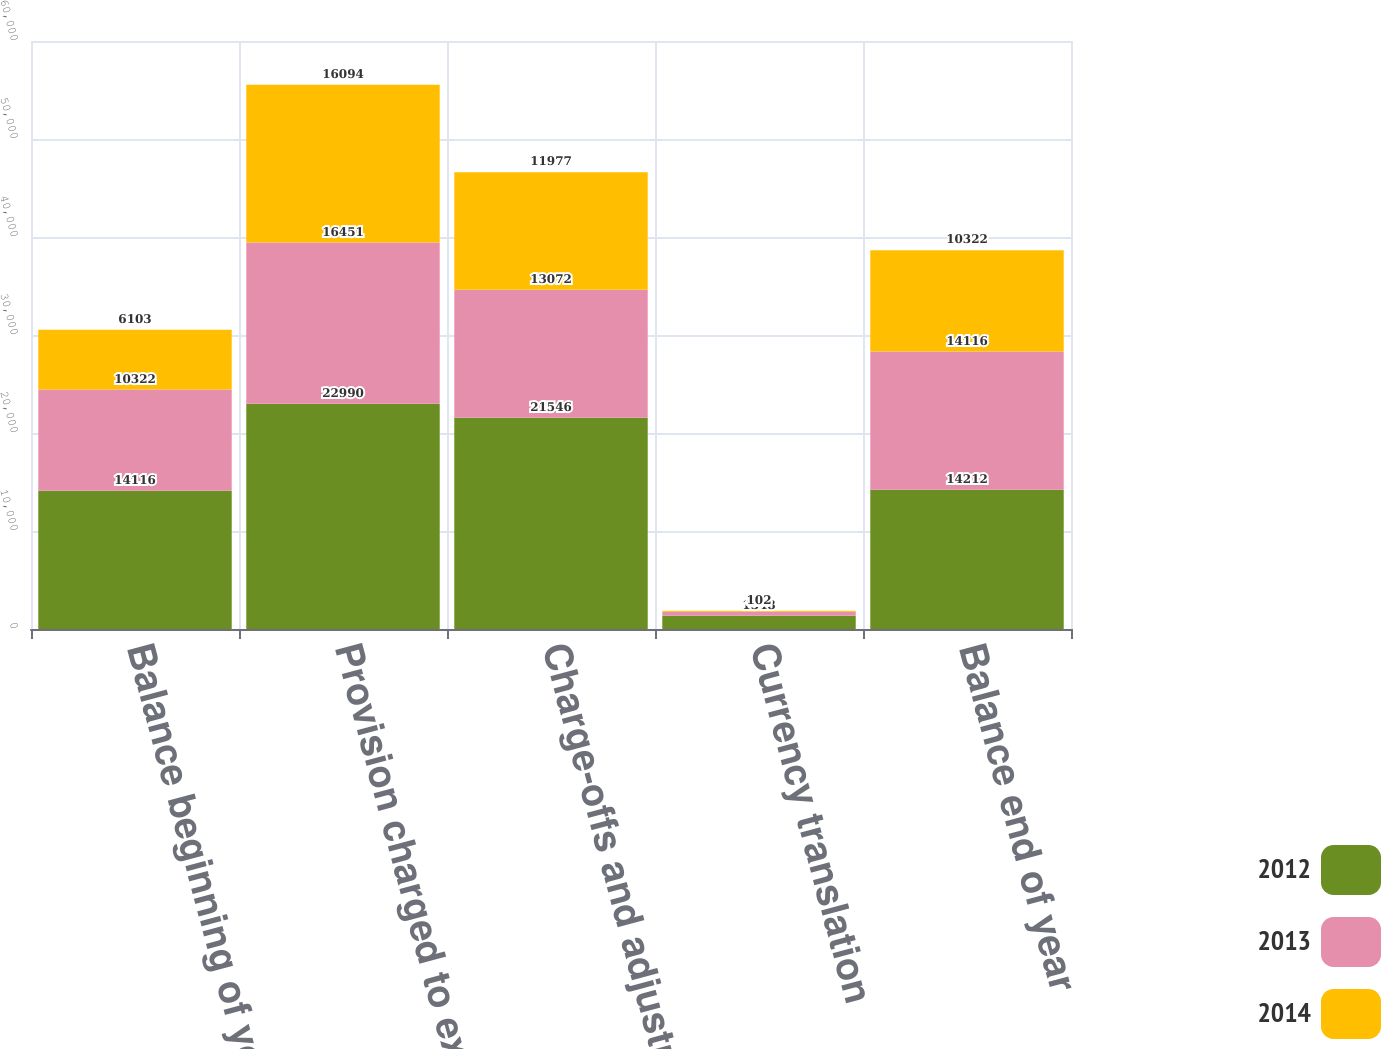Convert chart. <chart><loc_0><loc_0><loc_500><loc_500><stacked_bar_chart><ecel><fcel>Balance beginning of year<fcel>Provision charged to expense<fcel>Charge-offs and adjustments<fcel>Currency translation<fcel>Balance end of year<nl><fcel>2012<fcel>14116<fcel>22990<fcel>21546<fcel>1348<fcel>14212<nl><fcel>2013<fcel>10322<fcel>16451<fcel>13072<fcel>415<fcel>14116<nl><fcel>2014<fcel>6103<fcel>16094<fcel>11977<fcel>102<fcel>10322<nl></chart> 